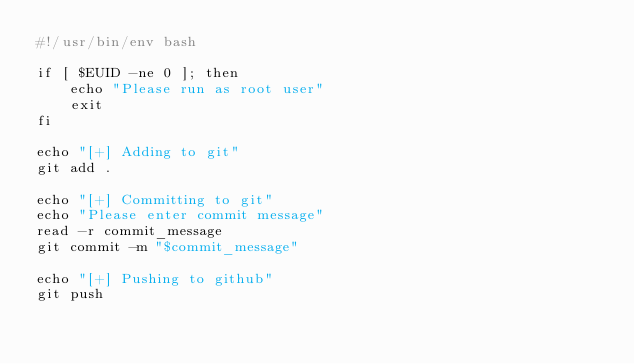Convert code to text. <code><loc_0><loc_0><loc_500><loc_500><_Bash_>#!/usr/bin/env bash

if [ $EUID -ne 0 ]; then
    echo "Please run as root user"
    exit
fi

echo "[+] Adding to git"
git add .

echo "[+] Committing to git"
echo "Please enter commit message"
read -r commit_message
git commit -m "$commit_message"

echo "[+] Pushing to github"
git push
</code> 